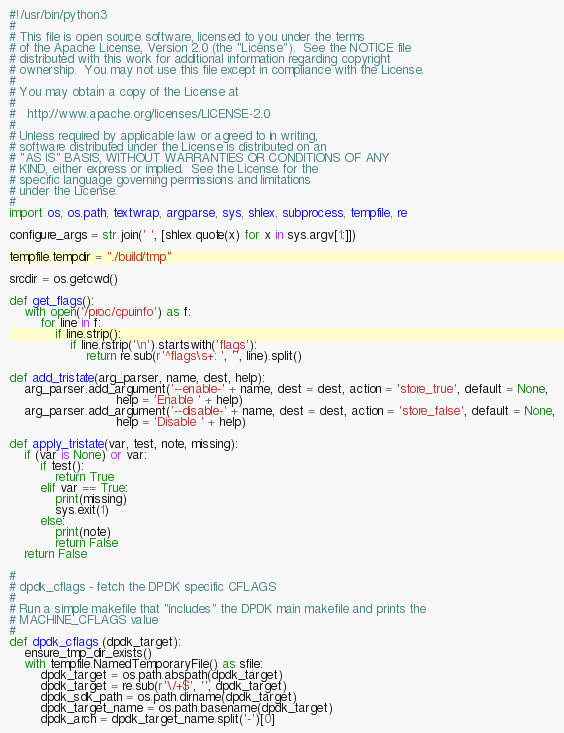<code> <loc_0><loc_0><loc_500><loc_500><_Python_>#!/usr/bin/python3
#
# This file is open source software, licensed to you under the terms
# of the Apache License, Version 2.0 (the "License").  See the NOTICE file
# distributed with this work for additional information regarding copyright
# ownership.  You may not use this file except in compliance with the License.
#
# You may obtain a copy of the License at
#
#   http://www.apache.org/licenses/LICENSE-2.0
#
# Unless required by applicable law or agreed to in writing,
# software distributed under the License is distributed on an
# "AS IS" BASIS, WITHOUT WARRANTIES OR CONDITIONS OF ANY
# KIND, either express or implied.  See the License for the
# specific language governing permissions and limitations
# under the License.
#
import os, os.path, textwrap, argparse, sys, shlex, subprocess, tempfile, re

configure_args = str.join(' ', [shlex.quote(x) for x in sys.argv[1:]])

tempfile.tempdir = "./build/tmp"

srcdir = os.getcwd()

def get_flags():
    with open('/proc/cpuinfo') as f:
        for line in f:
            if line.strip():
                if line.rstrip('\n').startswith('flags'):
                    return re.sub(r'^flags\s+: ', '', line).split()

def add_tristate(arg_parser, name, dest, help):
    arg_parser.add_argument('--enable-' + name, dest = dest, action = 'store_true', default = None,
                            help = 'Enable ' + help)
    arg_parser.add_argument('--disable-' + name, dest = dest, action = 'store_false', default = None,
                            help = 'Disable ' + help)

def apply_tristate(var, test, note, missing):
    if (var is None) or var:
        if test():
            return True
        elif var == True:
            print(missing)
            sys.exit(1)
        else:
            print(note)
            return False
    return False

#
# dpdk_cflags - fetch the DPDK specific CFLAGS
#
# Run a simple makefile that "includes" the DPDK main makefile and prints the
# MACHINE_CFLAGS value
#
def dpdk_cflags (dpdk_target):
    ensure_tmp_dir_exists()
    with tempfile.NamedTemporaryFile() as sfile:
        dpdk_target = os.path.abspath(dpdk_target)
        dpdk_target = re.sub(r'\/+$', '', dpdk_target)
        dpdk_sdk_path = os.path.dirname(dpdk_target)
        dpdk_target_name = os.path.basename(dpdk_target)
        dpdk_arch = dpdk_target_name.split('-')[0]</code> 